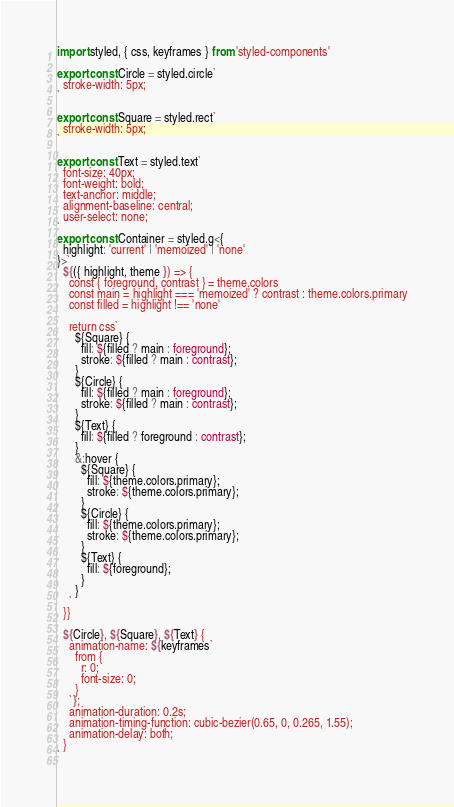<code> <loc_0><loc_0><loc_500><loc_500><_TypeScript_>import styled, { css, keyframes } from 'styled-components'

export const Circle = styled.circle`
  stroke-width: 5px;
`

export const Square = styled.rect`
  stroke-width: 5px;
`

export const Text = styled.text`
  font-size: 40px;
  font-weight: bold;
  text-anchor: middle;
  alignment-baseline: central;
  user-select: none;
`
export const Container = styled.g<{
  highlight: 'current' | 'memoized' | 'none'
}>`
  ${({ highlight, theme }) => {
    const { foreground, contrast } = theme.colors
    const main = highlight === 'memoized' ? contrast : theme.colors.primary
    const filled = highlight !== 'none'

    return css`
      ${Square} {
        fill: ${filled ? main : foreground};
        stroke: ${filled ? main : contrast};
      }
      ${Circle} {
        fill: ${filled ? main : foreground};
        stroke: ${filled ? main : contrast};
      }
      ${Text} {
        fill: ${filled ? foreground : contrast};
      }
      &:hover {
        ${Square} {
          fill: ${theme.colors.primary};
          stroke: ${theme.colors.primary};
        }
        ${Circle} {
          fill: ${theme.colors.primary};
          stroke: ${theme.colors.primary};
        }
        ${Text} {
          fill: ${foreground};
        }
      }
    `
  }}

  ${Circle}, ${Square}, ${Text} {
    animation-name: ${keyframes`
      from {
        r: 0;
        font-size: 0;
      }
    `};
    animation-duration: 0.2s;
    animation-timing-function: cubic-bezier(0.65, 0, 0.265, 1.55);
    animation-delay: both;
  }
`
</code> 